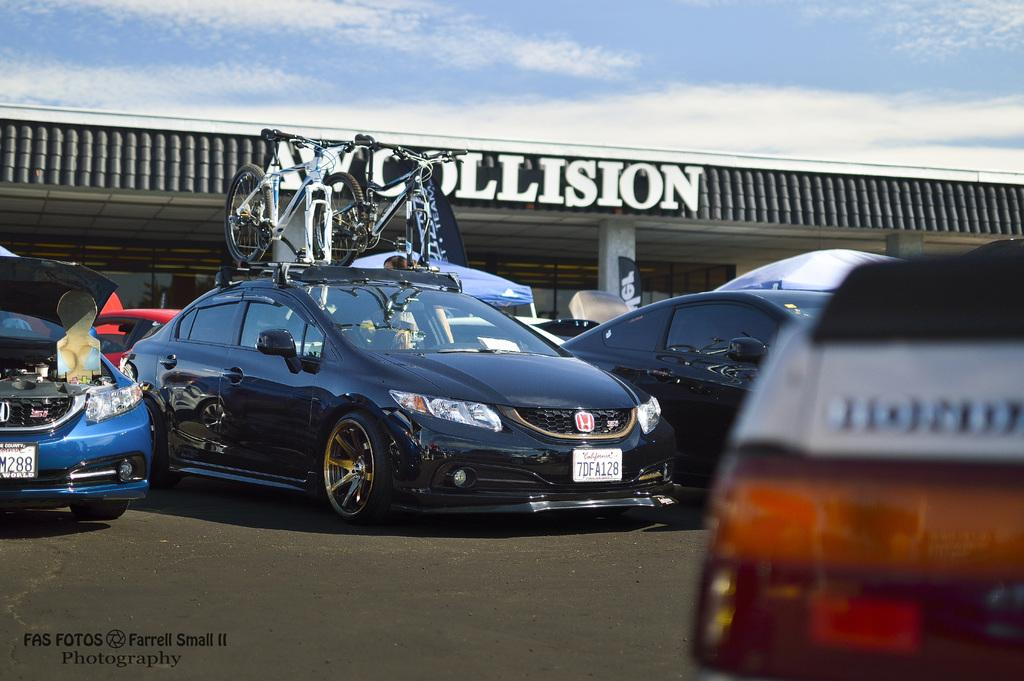<image>
Provide a brief description of the given image. A car with bicycles on top in front of a collision repair business. 